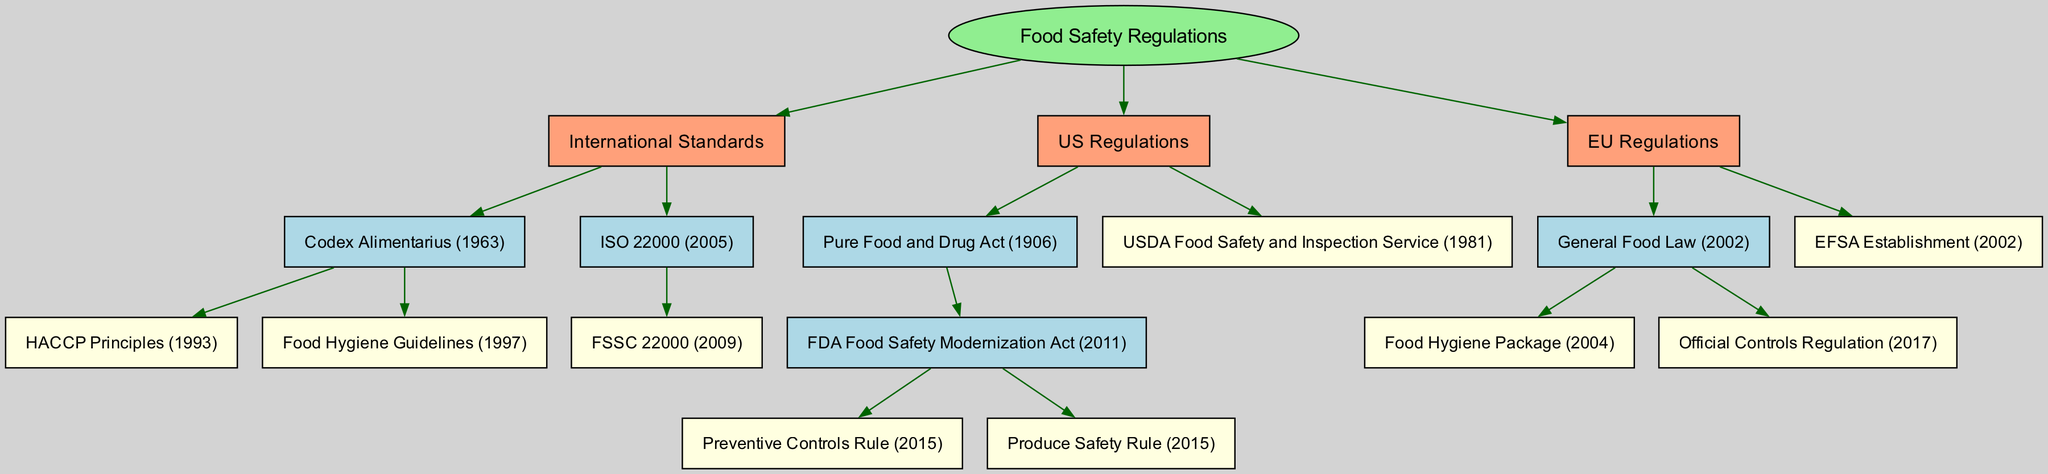What is the root of the family tree? The root of the family tree is labeled as "Food Safety Regulations." This is the topmost node from which all other branches and nodes stem.
Answer: Food Safety Regulations How many main branches are there? In the diagram, there are three main branches labeled "International Standards," "US Regulations," and "EU Regulations." Each of these branches represents a distinct category within the overall food safety regulations structure.
Answer: 3 What are the two children of "Codex Alimentarius"? The two children beneath the "Codex Alimentarius" node are "HACCP Principles" and "Food Hygiene Guidelines." These are specific standards developed after the establishment of the Codex Alimentarius in 1963.
Answer: HACCP Principles, Food Hygiene Guidelines Which act was established first: the Pure Food and Drug Act or the FDA Food Safety Modernization Act? According to the diagram, the "Pure Food and Drug Act" was established in 1906, while the "FDA Food Safety Modernization Act" came later in 2011. Therefore, the Pure Food and Drug Act is the earlier act.
Answer: Pure Food and Drug Act Which regulation is a child of "General Food Law"? The "Food Hygiene Package" and the "Official Controls Regulation" are both children under the "General Food Law" node established in 2002. Each of these represents components of food safety regulations in the European Union.
Answer: Food Hygiene Package What are the years associated with the establishment of ISO 22000 and FSSC 22000? "ISO 22000" was established in 2005 and its child, "FSSC 22000," was established later in 2009. These years indicate the development timeline of these international food safety standards.
Answer: 2005, 2009 How many children does "USDA Food Safety and Inspection Service" have? The node "USDA Food Safety and Inspection Service" does not have any children listed within the diagram. It stands alone as a key regulatory body without further subdivisions in this diagram context.
Answer: 0 Which node has the most children? The "Pure Food and Drug Act" has the most children, specifically two: "FDA Food Safety Modernization Act," which further branches into "Preventive Controls Rule" and "Produce Safety Rule." This hierarchy shows a more intricate relationship compared to other nodes.
Answer: Pure Food and Drug Act What is the relationship between Codex Alimentarius and ISO 22000? Both "Codex Alimentarius" and "ISO 22000" are children of the "International Standards" branch. This indicates that they both fall under the same category of food safety regulations at the international level, highlighting their significance in food safety standards globally.
Answer: Sibling relationship 